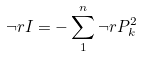<formula> <loc_0><loc_0><loc_500><loc_500>\neg r I = - \sum _ { 1 } ^ { n } \neg r P _ { k } ^ { 2 }</formula> 